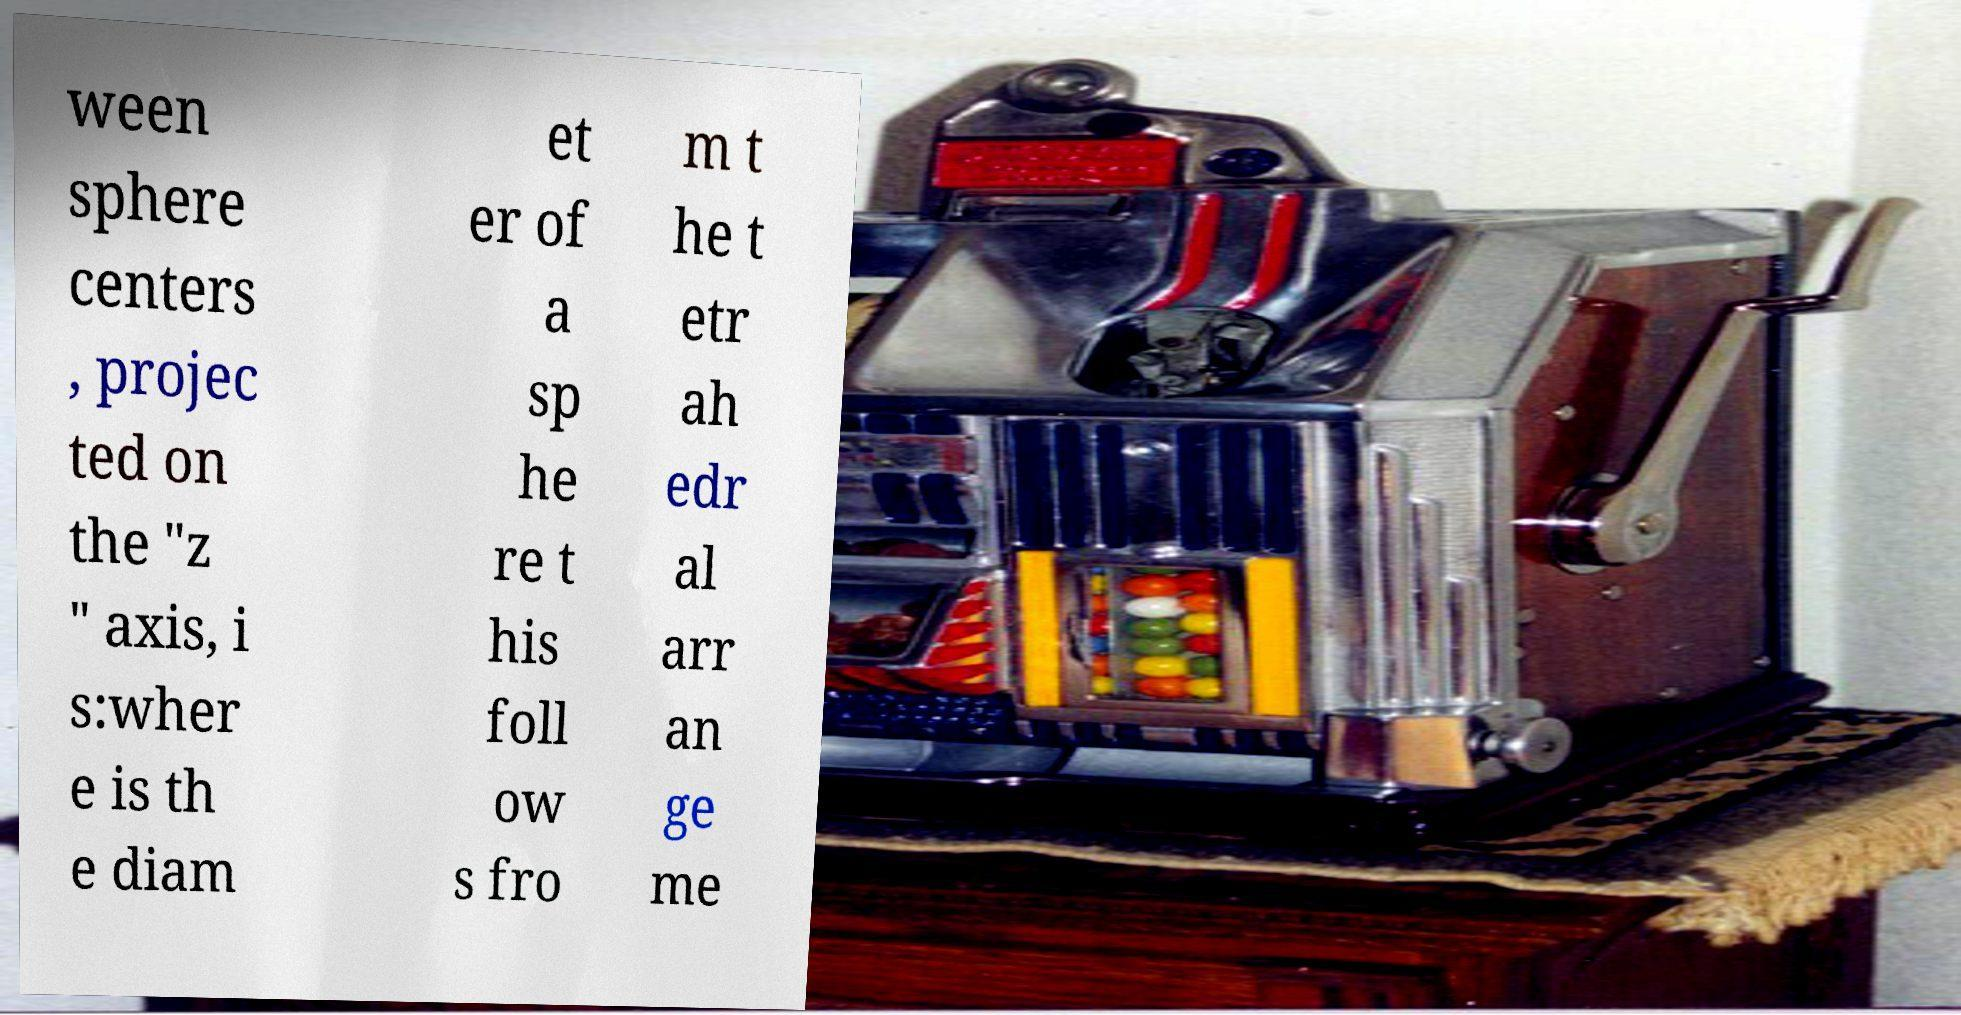Can you read and provide the text displayed in the image?This photo seems to have some interesting text. Can you extract and type it out for me? ween sphere centers , projec ted on the "z " axis, i s:wher e is th e diam et er of a sp he re t his foll ow s fro m t he t etr ah edr al arr an ge me 